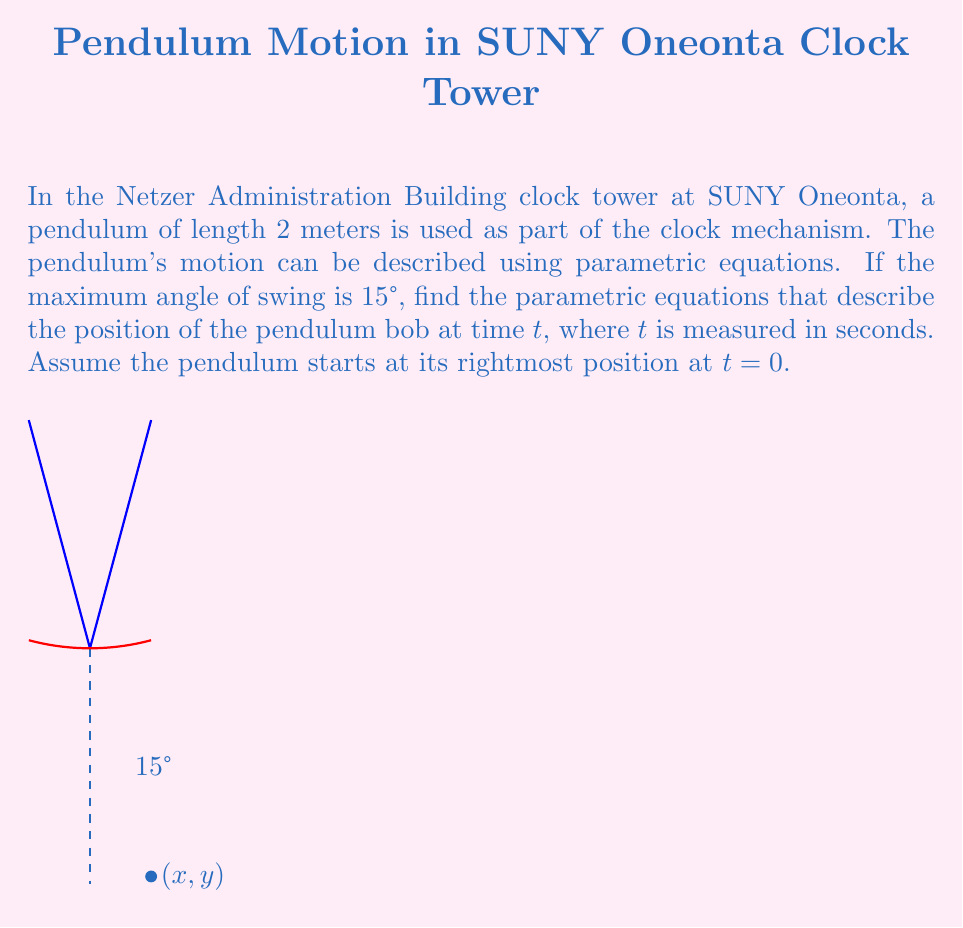Show me your answer to this math problem. Let's approach this step-by-step:

1) The motion of a simple pendulum can be approximated by simple harmonic motion for small angles.

2) The angular frequency $\omega$ of the pendulum is given by:
   $$\omega = \sqrt{\frac{g}{L}}$$
   where $g$ is the acceleration due to gravity (9.8 m/s²) and $L$ is the length of the pendulum.

3) Substituting the values:
   $$\omega = \sqrt{\frac{9.8}{2}} \approx 2.21 \text{ rad/s}$$

4) The maximum displacement of the pendulum bob in the x-direction is:
   $$A = L \sin(\theta_{max}) = 2 \sin(15°) \approx 0.518 \text{ m}$$

5) The parametric equations for the position of the pendulum bob are:
   $$x = A \cos(\omega t)$$
   $$y = -L \cos(\theta) = -\sqrt{L^2 - x^2}$$

6) Substituting the values we calculated:
   $$x = 0.518 \cos(2.21t)$$
   $$y = -\sqrt{2^2 - x^2} = -\sqrt{4 - (0.518 \cos(2.21t))^2}$$

These equations describe the position (x, y) of the pendulum bob at any time t.
Answer: $x = 0.518 \cos(2.21t)$, $y = -\sqrt{4 - (0.518 \cos(2.21t))^2}$ 